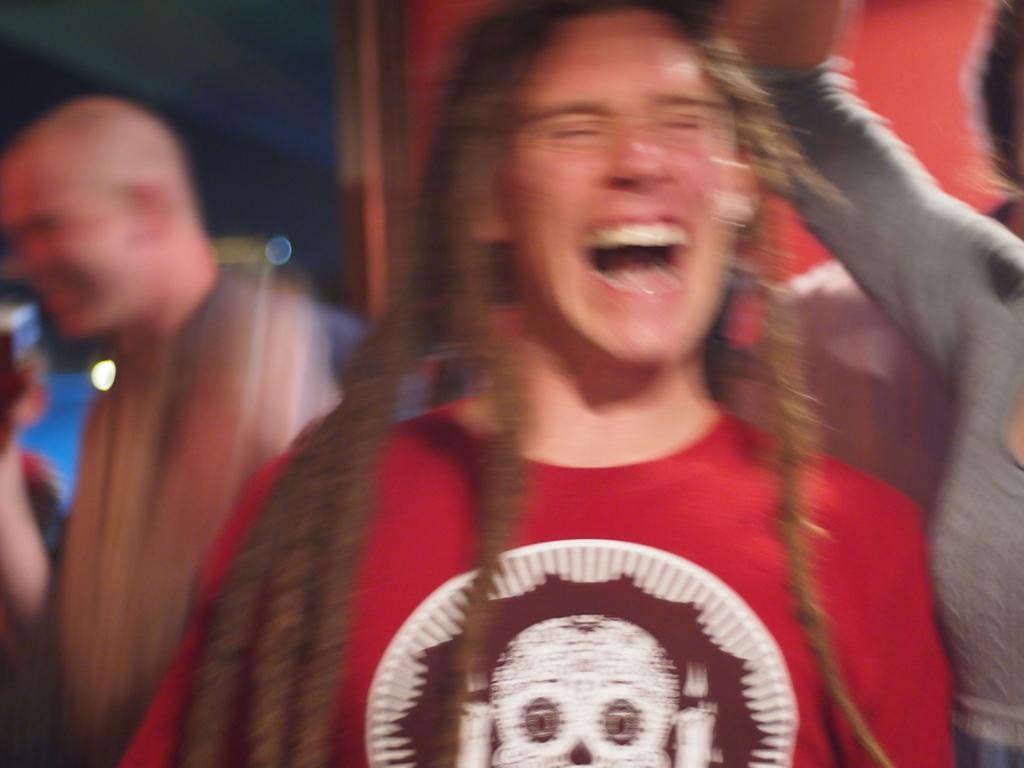Can you describe this image briefly? In this picture I can see few people standing and I can see blurry background. 